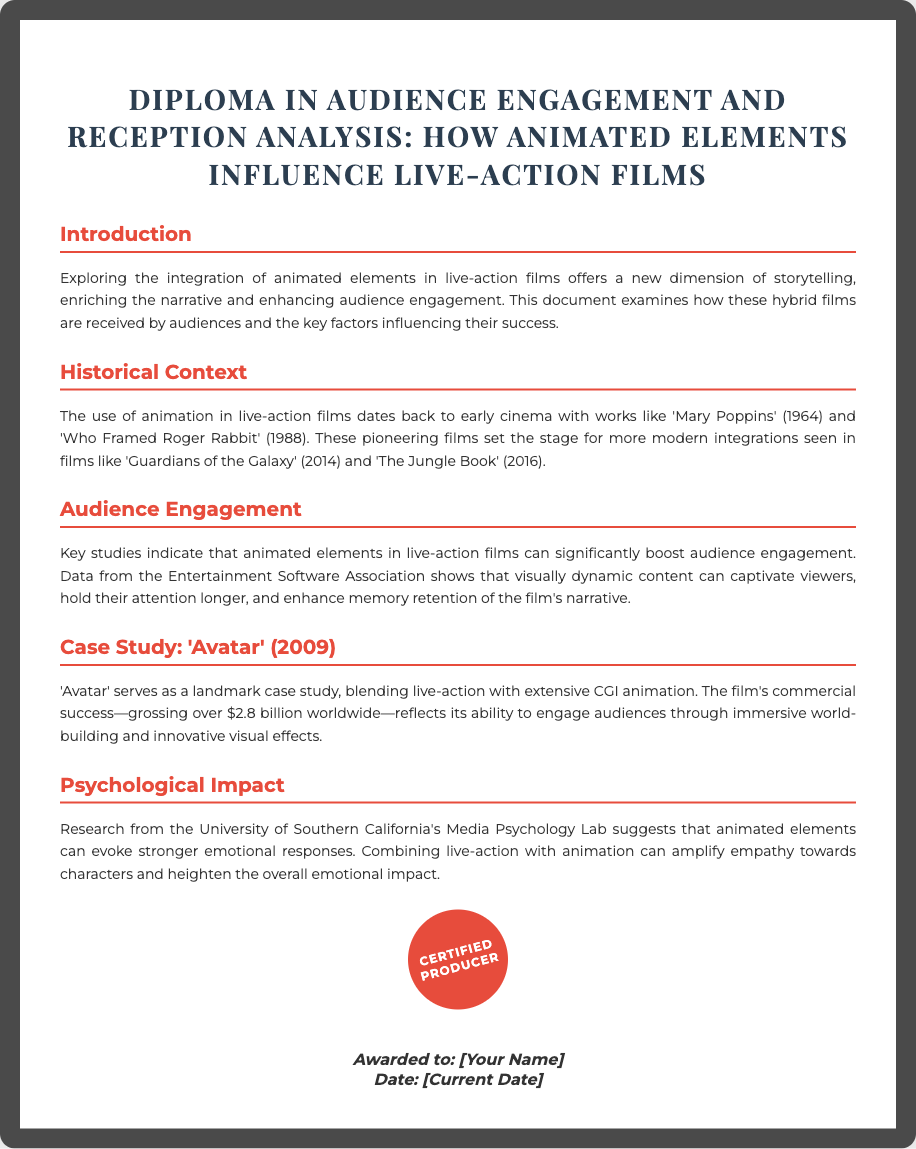what is the title of the diploma? The title of the diploma is explicitly stated at the beginning of the document.
Answer: Diploma in Audience Engagement and Reception Analysis: How Animated Elements Influence Live-Action Films which film was highlighted as a landmark case study? The document specifically mentions one film as a landmark case study in the integration of animation and live-action.
Answer: Avatar (2009) how much did 'Avatar' gross worldwide? The document provides the exact figure for the total gross of 'Avatar'.
Answer: over $2.8 billion what year was 'Mary Poppins' released? The document references the release year of 'Mary Poppins' as part of the historical context.
Answer: 1964 which university conducted research on the psychological impact of animated elements? The document cites a specific university known for its research in media psychology.
Answer: University of Southern California how many films are mentioned in the historical context section? The document lists three films in the historical context section.
Answer: Three what is one effect of animated elements on audience engagement according to the document? The document outlines the impact of animated elements on audience engagement in terms of viewer attention.
Answer: enhances memory retention what color is the diploma's border? The document describes the visual design features of the diploma, including its border color.
Answer: #4a4a4a what is the seal on the diploma labeled as? The document describes the seal and its designation on the diploma.
Answer: Certified Producer 